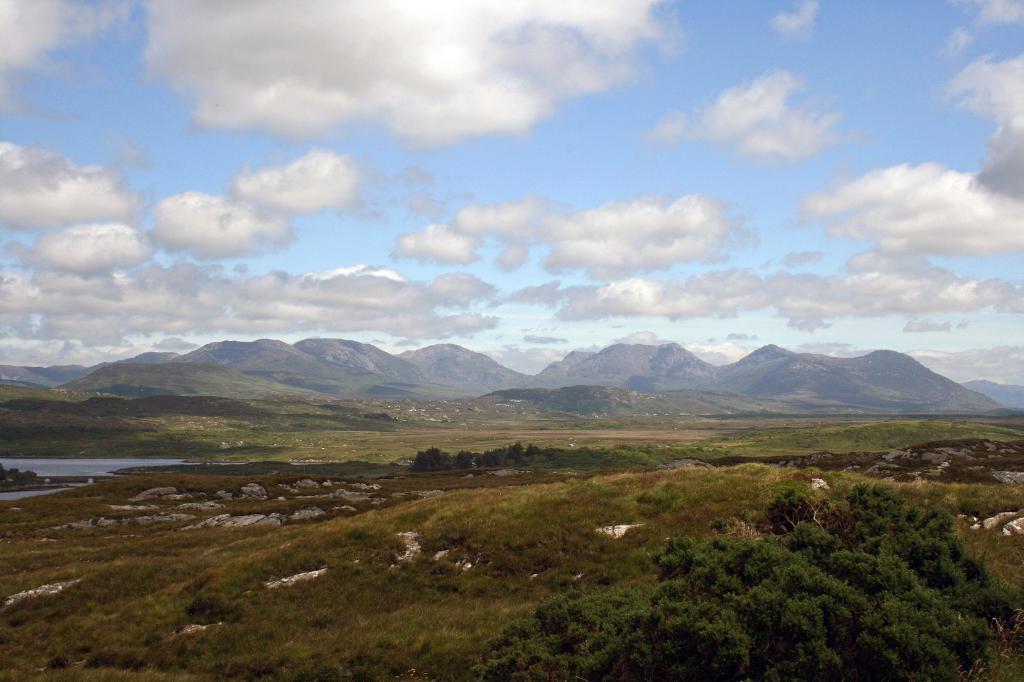Can you describe this image briefly? In this image I can see the trees in green color and I can also see the water. Background I can see the mountains and the sky is in blue and white color. 